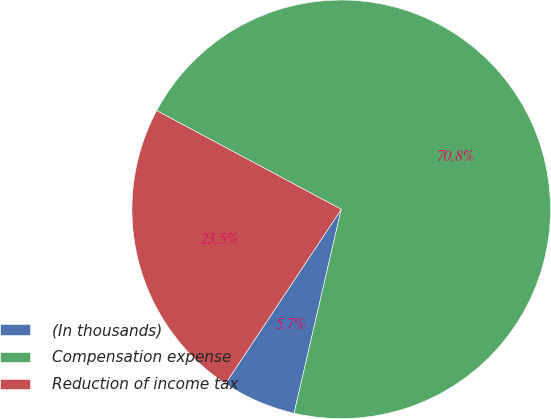<chart> <loc_0><loc_0><loc_500><loc_500><pie_chart><fcel>(In thousands)<fcel>Compensation expense<fcel>Reduction of income tax<nl><fcel>5.71%<fcel>70.8%<fcel>23.49%<nl></chart> 